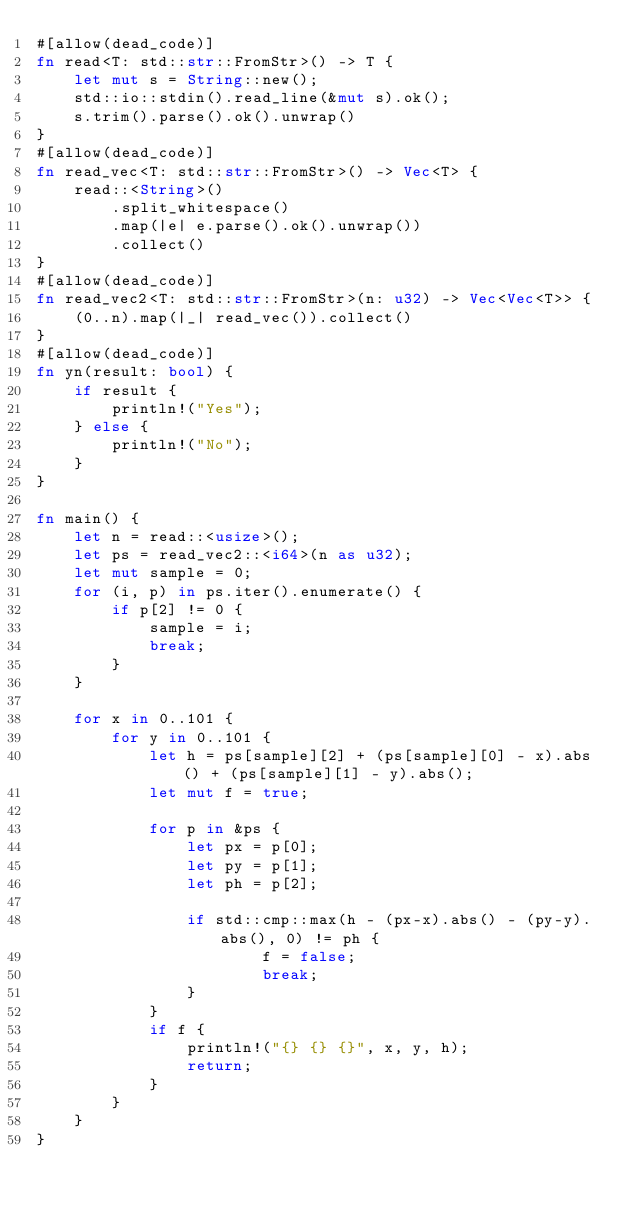Convert code to text. <code><loc_0><loc_0><loc_500><loc_500><_Rust_>#[allow(dead_code)]
fn read<T: std::str::FromStr>() -> T {
    let mut s = String::new();
    std::io::stdin().read_line(&mut s).ok();
    s.trim().parse().ok().unwrap()
}
#[allow(dead_code)]
fn read_vec<T: std::str::FromStr>() -> Vec<T> {
    read::<String>()
        .split_whitespace()
        .map(|e| e.parse().ok().unwrap())
        .collect()
}
#[allow(dead_code)]
fn read_vec2<T: std::str::FromStr>(n: u32) -> Vec<Vec<T>> {
    (0..n).map(|_| read_vec()).collect()
}
#[allow(dead_code)]
fn yn(result: bool) {
    if result {
        println!("Yes");
    } else {
        println!("No");
    }
}

fn main() {
    let n = read::<usize>();
    let ps = read_vec2::<i64>(n as u32);
    let mut sample = 0;
    for (i, p) in ps.iter().enumerate() {
        if p[2] != 0 {
            sample = i;
            break;
        }
    }

    for x in 0..101 {
        for y in 0..101 {
            let h = ps[sample][2] + (ps[sample][0] - x).abs() + (ps[sample][1] - y).abs();
            let mut f = true;

            for p in &ps {
                let px = p[0];
                let py = p[1];
                let ph = p[2];

                if std::cmp::max(h - (px-x).abs() - (py-y).abs(), 0) != ph {
                        f = false;
                        break;
                }
            }
            if f {
                println!("{} {} {}", x, y, h);
                return;
            }
        }
    }
}
</code> 